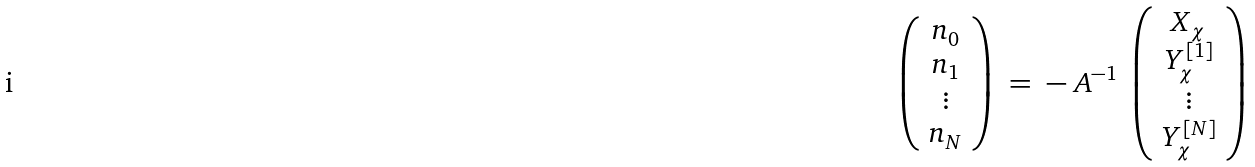Convert formula to latex. <formula><loc_0><loc_0><loc_500><loc_500>\left ( \begin{array} { c } n _ { 0 } \\ n _ { 1 } \\ \vdots \\ n _ { N } \end{array} \right ) \ = \ - \ A ^ { - 1 } \ \left ( \begin{array} { c } X _ { \chi } \\ Y ^ { [ 1 ] } _ { \chi } \\ \vdots \\ Y ^ { [ N ] } _ { \chi } \end{array} \right )</formula> 